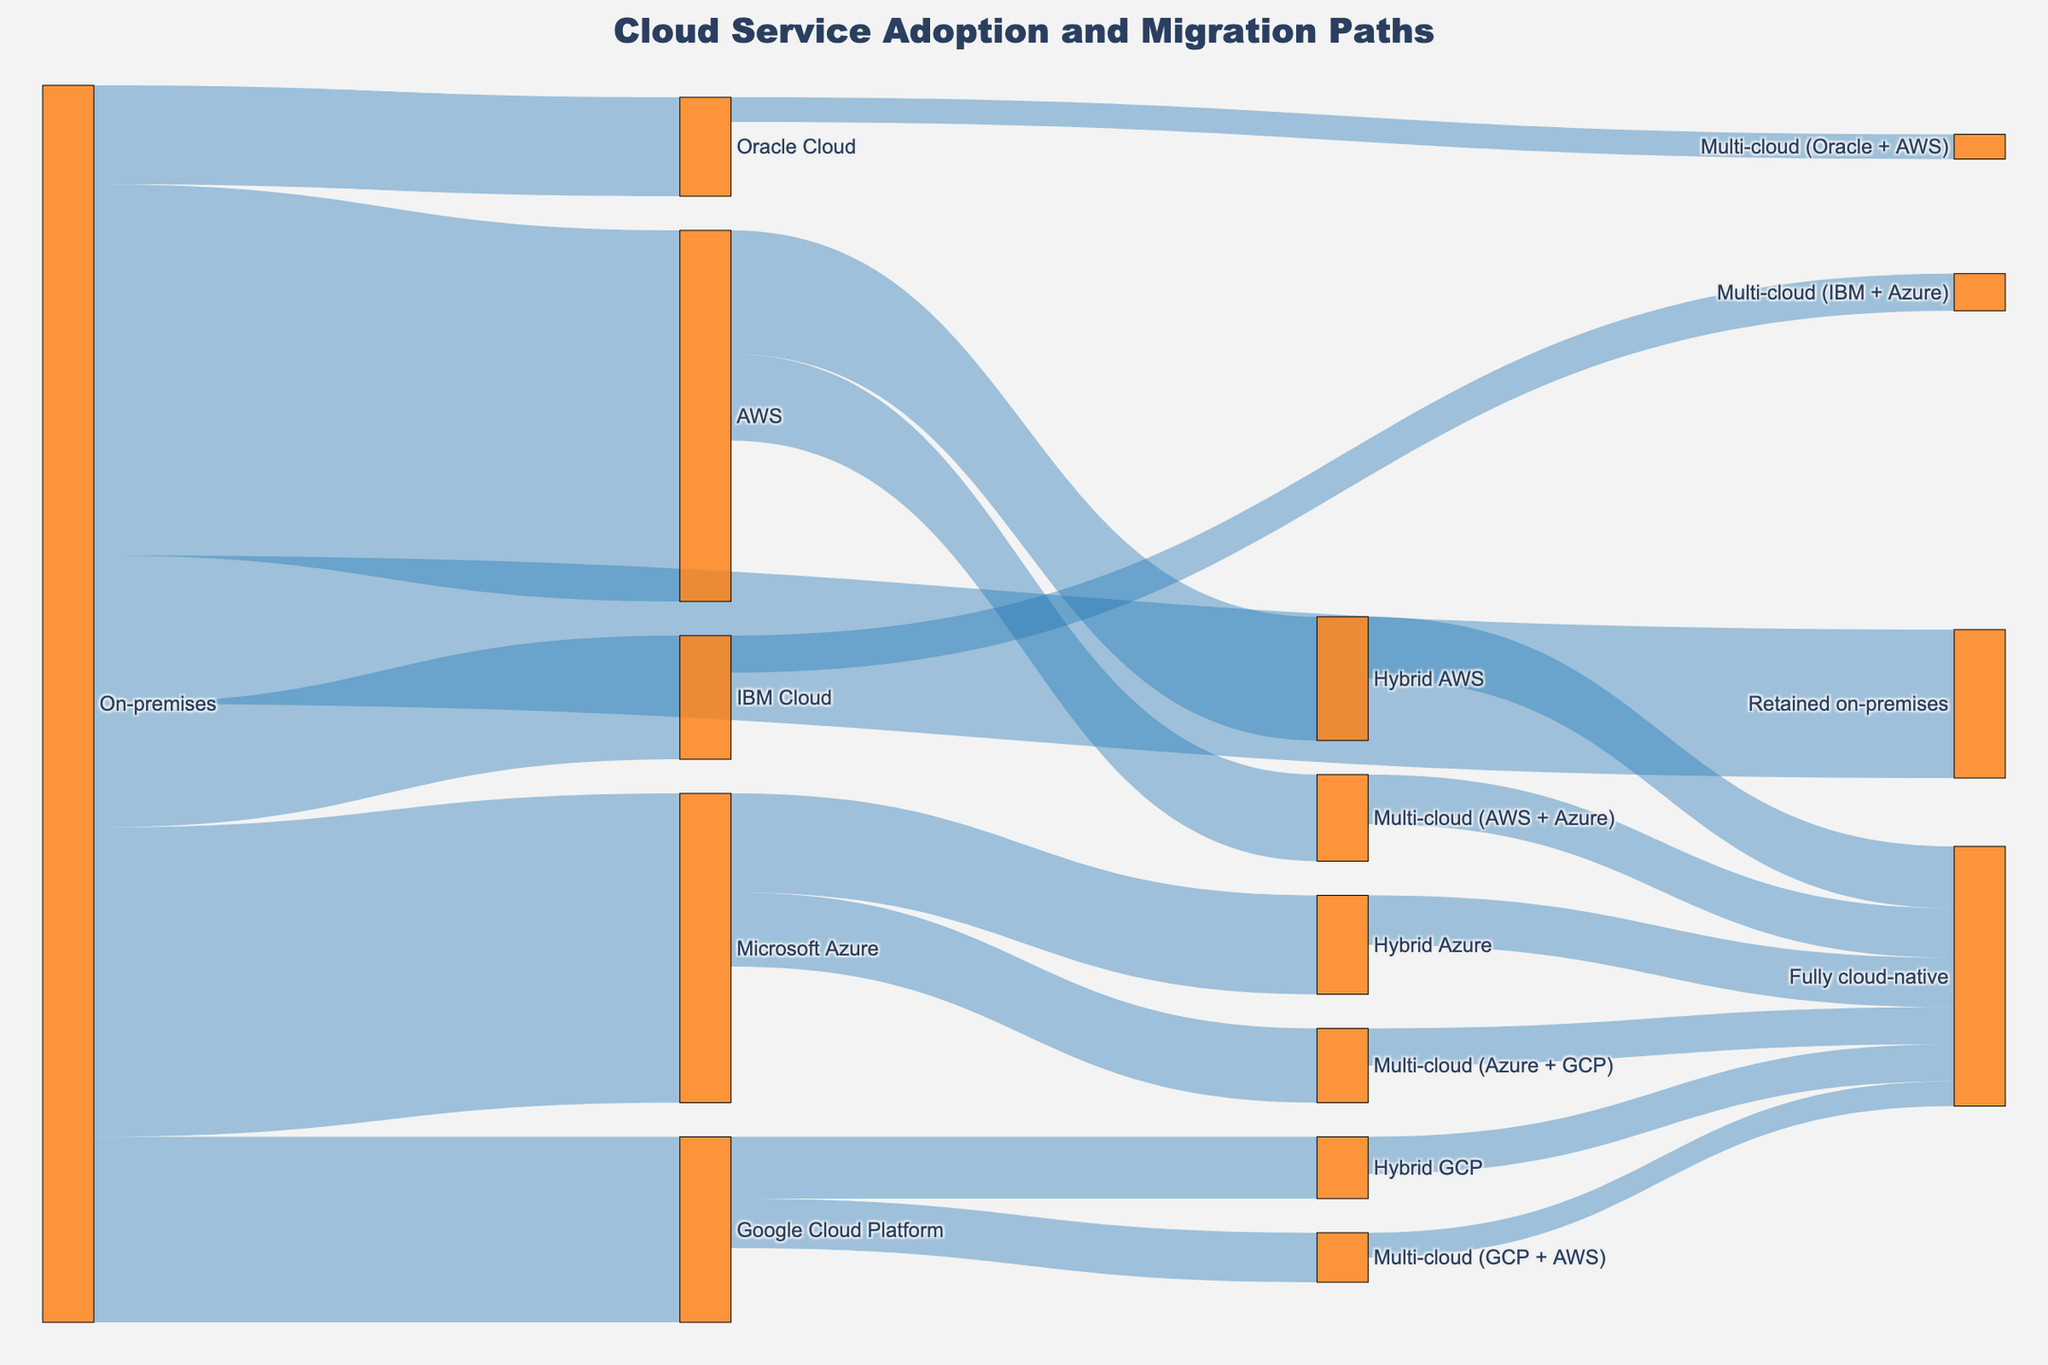What is the title of the figure? The title of the figure is displayed prominently at the top of the plot. It helps identify what the figure is about. In this case, the title text is "Cloud Service Adoption and Migration Paths".
Answer: Cloud Service Adoption and Migration Paths How many enterprise customers retained their on-premises setup? To find this information, look at the flow from "On-premises" to "Retained on-premises". The width of the flow represents the value.
Answer: 12 Which cloud platform received the highest number of migrations from on-premises? Look at the flows starting from "On-premises" and see which flow has the widest path, indicating the largest number of migrations.
Answer: AWS How many customers have adopted a fully cloud-native setup after a hybrid approach? Identify the flows leading to "Fully cloud-native" from any "Hybrid" nodes and sum their values.
Answer: 12 What is the combined number of customers that moved to AWS and Microsoft Azure from on-premises? Add the values of the flows from "On-premises" to "AWS" and "Microsoft Azure". The values are 30 and 25 respectively. Therefore, the combined number is 30 + 25.
Answer: 55 Which migration path results in the smallest number of customers? Look at all the flows and identify the one with the smallest width or value.
Answer: Multi-cloud (Oracle + AWS) How many enterprise customers adopted multi-cloud setups involving Azure? Identify the flows leading to multi-cloud setups that include "Azure". Add the values of "Multi-cloud (AWS + Azure)", "Multi-cloud (IBM + Azure)", and "Multi-cloud (Azure + GCP)". The values are 7, 3, and 6 respectively. Thus, the total is 7 + 3 + 6.
Answer: 16 Which stage has the highest number of enterprise customers before moving onto "Fully cloud-native"? Check all flows leading to "Fully cloud-native" and identify the node with the highest number of outgoing customers to this stage, summing where necessary.
Answer: Hybrid AWS What is the total number of enterprise customers migrating to hybrid cloud setups from individual cloud platforms? Sum the values of flows leading from "AWS", "Microsoft Azure", and "Google Cloud Platform" to their respective hybrid nodes. The values are 10, 8, and 5 respectively. Therefore, the total is 10 + 8 + 5.
Answer: 23 